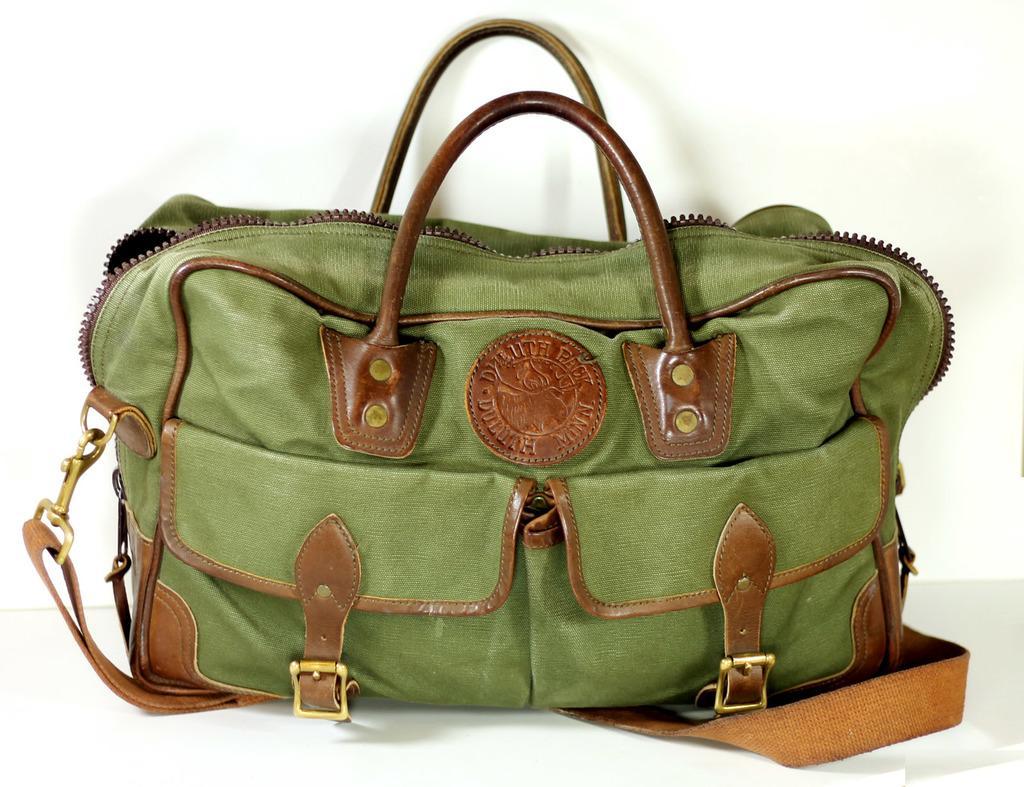Please provide a concise description of this image. in this picture there is a bag. 